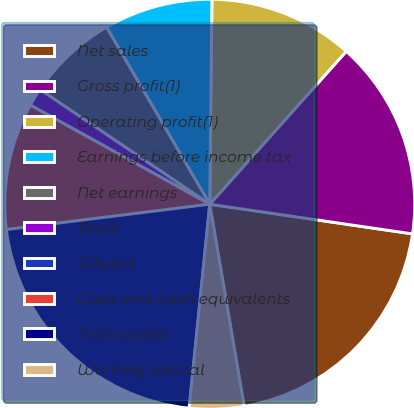<chart> <loc_0><loc_0><loc_500><loc_500><pie_chart><fcel>Net sales<fcel>Gross profit(1)<fcel>Operating profit(1)<fcel>Earnings before income tax<fcel>Net earnings<fcel>Basic<fcel>Diluted<fcel>Cash and cash equivalents<fcel>Total assets<fcel>Working capital<nl><fcel>20.0%<fcel>15.71%<fcel>11.43%<fcel>8.57%<fcel>7.14%<fcel>1.43%<fcel>0.0%<fcel>10.0%<fcel>21.42%<fcel>4.29%<nl></chart> 